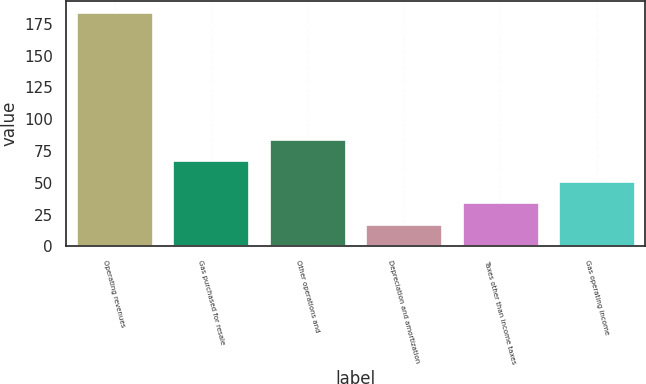Convert chart. <chart><loc_0><loc_0><loc_500><loc_500><bar_chart><fcel>Operating revenues<fcel>Gas purchased for resale<fcel>Other operations and<fcel>Depreciation and amortization<fcel>Taxes other than income taxes<fcel>Gas operating income<nl><fcel>184<fcel>67.8<fcel>84.4<fcel>18<fcel>34.6<fcel>51.2<nl></chart> 